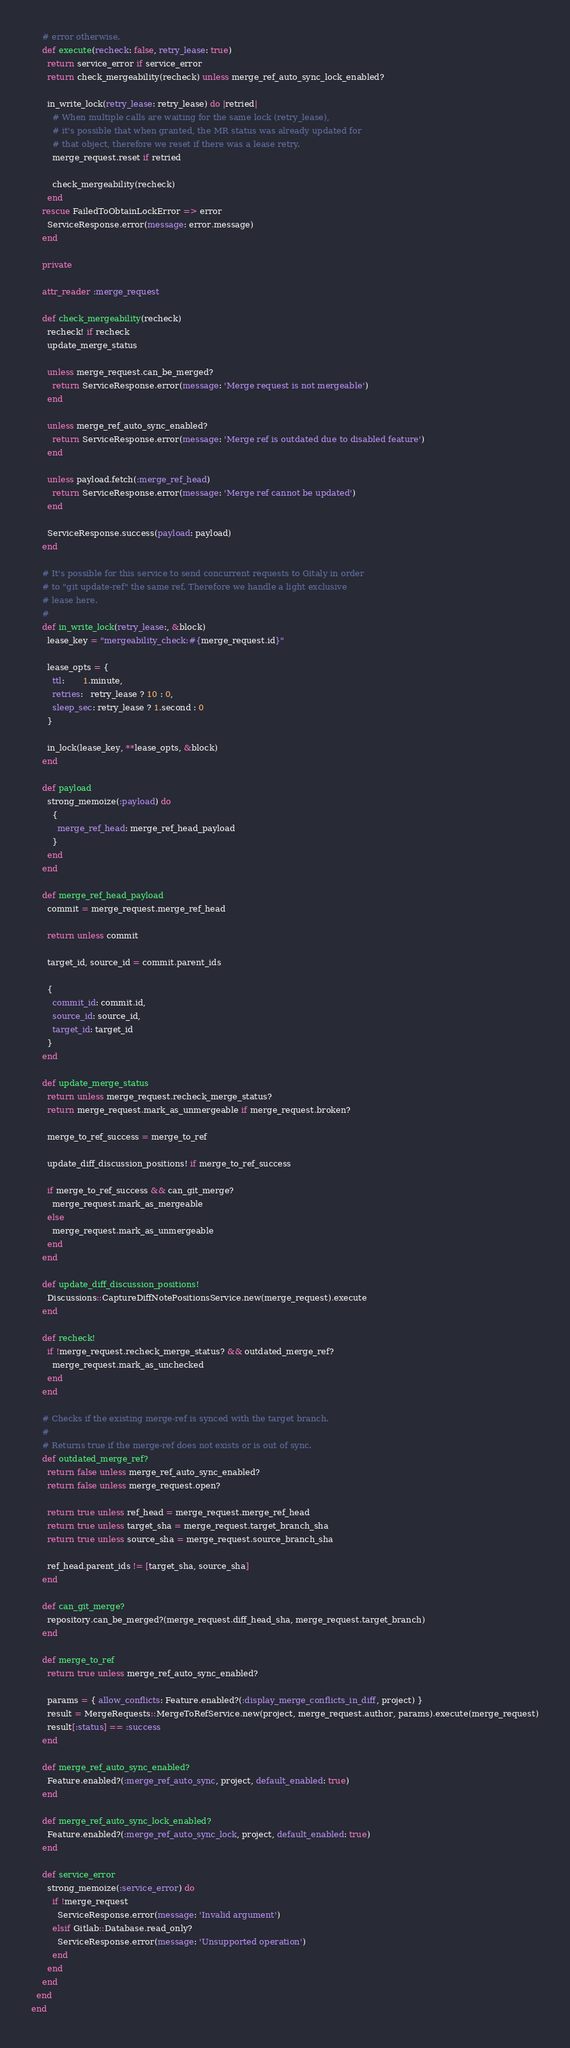Convert code to text. <code><loc_0><loc_0><loc_500><loc_500><_Ruby_>    # error otherwise.
    def execute(recheck: false, retry_lease: true)
      return service_error if service_error
      return check_mergeability(recheck) unless merge_ref_auto_sync_lock_enabled?

      in_write_lock(retry_lease: retry_lease) do |retried|
        # When multiple calls are waiting for the same lock (retry_lease),
        # it's possible that when granted, the MR status was already updated for
        # that object, therefore we reset if there was a lease retry.
        merge_request.reset if retried

        check_mergeability(recheck)
      end
    rescue FailedToObtainLockError => error
      ServiceResponse.error(message: error.message)
    end

    private

    attr_reader :merge_request

    def check_mergeability(recheck)
      recheck! if recheck
      update_merge_status

      unless merge_request.can_be_merged?
        return ServiceResponse.error(message: 'Merge request is not mergeable')
      end

      unless merge_ref_auto_sync_enabled?
        return ServiceResponse.error(message: 'Merge ref is outdated due to disabled feature')
      end

      unless payload.fetch(:merge_ref_head)
        return ServiceResponse.error(message: 'Merge ref cannot be updated')
      end

      ServiceResponse.success(payload: payload)
    end

    # It's possible for this service to send concurrent requests to Gitaly in order
    # to "git update-ref" the same ref. Therefore we handle a light exclusive
    # lease here.
    #
    def in_write_lock(retry_lease:, &block)
      lease_key = "mergeability_check:#{merge_request.id}"

      lease_opts = {
        ttl:       1.minute,
        retries:   retry_lease ? 10 : 0,
        sleep_sec: retry_lease ? 1.second : 0
      }

      in_lock(lease_key, **lease_opts, &block)
    end

    def payload
      strong_memoize(:payload) do
        {
          merge_ref_head: merge_ref_head_payload
        }
      end
    end

    def merge_ref_head_payload
      commit = merge_request.merge_ref_head

      return unless commit

      target_id, source_id = commit.parent_ids

      {
        commit_id: commit.id,
        source_id: source_id,
        target_id: target_id
      }
    end

    def update_merge_status
      return unless merge_request.recheck_merge_status?
      return merge_request.mark_as_unmergeable if merge_request.broken?

      merge_to_ref_success = merge_to_ref

      update_diff_discussion_positions! if merge_to_ref_success

      if merge_to_ref_success && can_git_merge?
        merge_request.mark_as_mergeable
      else
        merge_request.mark_as_unmergeable
      end
    end

    def update_diff_discussion_positions!
      Discussions::CaptureDiffNotePositionsService.new(merge_request).execute
    end

    def recheck!
      if !merge_request.recheck_merge_status? && outdated_merge_ref?
        merge_request.mark_as_unchecked
      end
    end

    # Checks if the existing merge-ref is synced with the target branch.
    #
    # Returns true if the merge-ref does not exists or is out of sync.
    def outdated_merge_ref?
      return false unless merge_ref_auto_sync_enabled?
      return false unless merge_request.open?

      return true unless ref_head = merge_request.merge_ref_head
      return true unless target_sha = merge_request.target_branch_sha
      return true unless source_sha = merge_request.source_branch_sha

      ref_head.parent_ids != [target_sha, source_sha]
    end

    def can_git_merge?
      repository.can_be_merged?(merge_request.diff_head_sha, merge_request.target_branch)
    end

    def merge_to_ref
      return true unless merge_ref_auto_sync_enabled?

      params = { allow_conflicts: Feature.enabled?(:display_merge_conflicts_in_diff, project) }
      result = MergeRequests::MergeToRefService.new(project, merge_request.author, params).execute(merge_request)
      result[:status] == :success
    end

    def merge_ref_auto_sync_enabled?
      Feature.enabled?(:merge_ref_auto_sync, project, default_enabled: true)
    end

    def merge_ref_auto_sync_lock_enabled?
      Feature.enabled?(:merge_ref_auto_sync_lock, project, default_enabled: true)
    end

    def service_error
      strong_memoize(:service_error) do
        if !merge_request
          ServiceResponse.error(message: 'Invalid argument')
        elsif Gitlab::Database.read_only?
          ServiceResponse.error(message: 'Unsupported operation')
        end
      end
    end
  end
end
</code> 